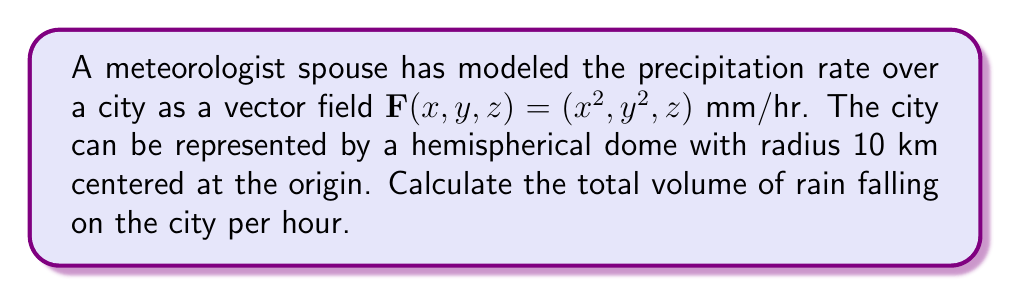Give your solution to this math problem. To solve this problem, we need to find the flux of the vector field through the hemispherical surface. We'll follow these steps:

1) The flux is given by the surface integral:
   $$\iint_S \mathbf{F} \cdot \mathbf{n} \, dS$$
   where $\mathbf{n}$ is the unit normal vector to the surface.

2) For a hemisphere of radius $r=10$ km, we can parametrize the surface using spherical coordinates:
   $$x = r\sin\theta\cos\phi, \, y = r\sin\theta\sin\phi, \, z = r\cos\theta$$
   where $0 \leq \theta \leq \frac{\pi}{2}$ and $0 \leq \phi \leq 2\pi$.

3) The unit normal vector for a sphere is $\mathbf{n} = (\sin\theta\cos\phi, \sin\theta\sin\phi, \cos\theta)$.

4) The surface element is $dS = r^2\sin\theta \, d\theta \, d\phi$.

5) Now, we can set up the integral:
   $$\iint_S \mathbf{F} \cdot \mathbf{n} \, dS = \int_0^{\frac{\pi}{2}} \int_0^{2\pi} (r^2\sin^3\theta\cos^3\phi + r^2\sin^3\theta\sin^3\phi + r\cos^2\theta) \cdot r^2\sin\theta \, d\phi \, d\theta$$

6) Simplify and integrate with respect to $\phi$:
   $$= r^4 \int_0^{\frac{\pi}{2}} \sin^4\theta \left(\int_0^{2\pi} (\cos^3\phi + \sin^3\phi) \, d\phi\right) \, d\theta + r^3 \int_0^{\frac{\pi}{2}} \cos^2\theta\sin\theta \, d\theta$$

7) The integral of $\cos^3\phi$ and $\sin^3\phi$ over $[0, 2\pi]$ is 0, so the first term vanishes.

8) Evaluate the remaining integral:
   $$= r^3 \int_0^{\frac{\pi}{2}} \cos^2\theta\sin\theta \, d\theta = r^3 \left[-\frac{1}{3}\cos^3\theta\right]_0^{\frac{\pi}{2}} = \frac{r^3}{3}$$

9) Substitute $r = 10$ km and convert to mm³/hr:
   $$\frac{(10 \text{ km})^3}{3} \cdot \left(\frac{10^6 \text{ mm}}{1 \text{ km}}\right)^3 = \frac{10^{21}}{3} \text{ mm}³/hr$$
Answer: $\frac{10^{21}}{3}$ mm³/hr 